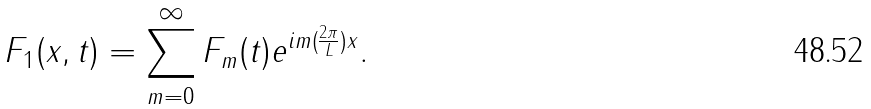<formula> <loc_0><loc_0><loc_500><loc_500>F _ { 1 } ( x , t ) = \sum _ { m = 0 } ^ { \infty } F _ { m } ( t ) e ^ { i m ( \frac { 2 \pi } { L } ) x } .</formula> 